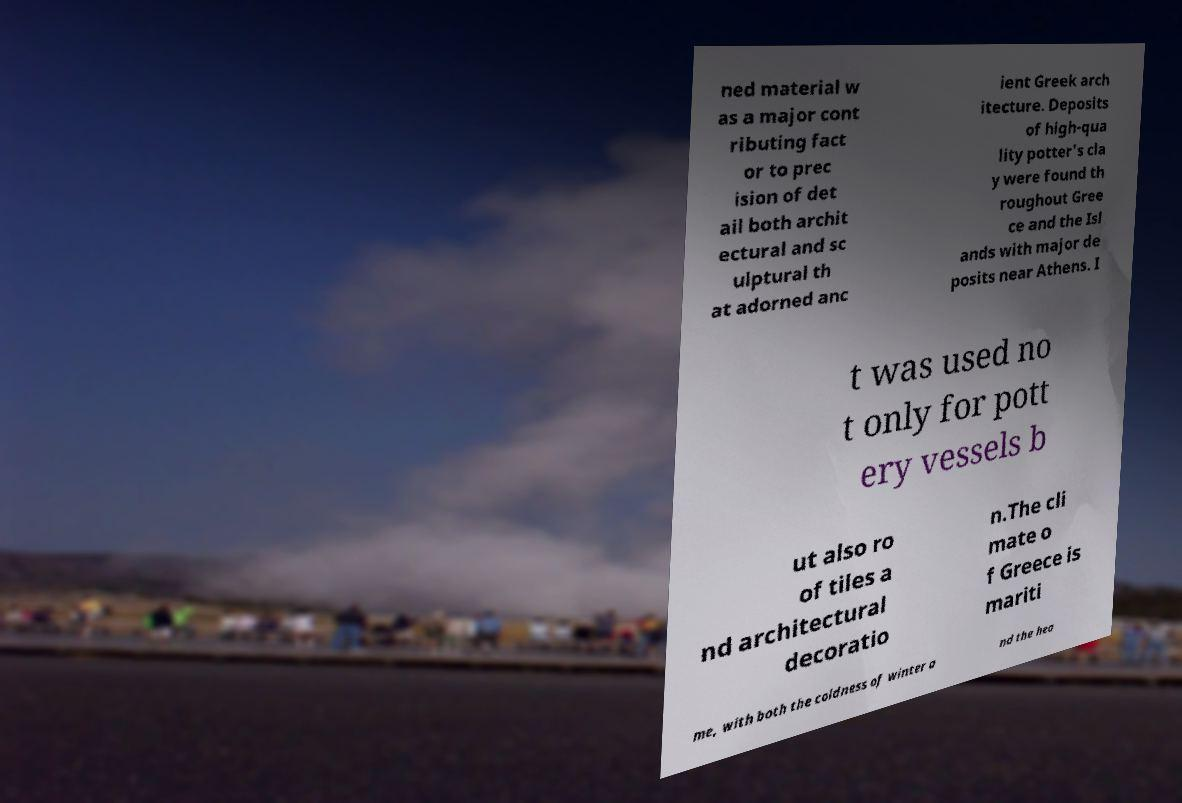Please identify and transcribe the text found in this image. ned material w as a major cont ributing fact or to prec ision of det ail both archit ectural and sc ulptural th at adorned anc ient Greek arch itecture. Deposits of high-qua lity potter's cla y were found th roughout Gree ce and the Isl ands with major de posits near Athens. I t was used no t only for pott ery vessels b ut also ro of tiles a nd architectural decoratio n.The cli mate o f Greece is mariti me, with both the coldness of winter a nd the hea 